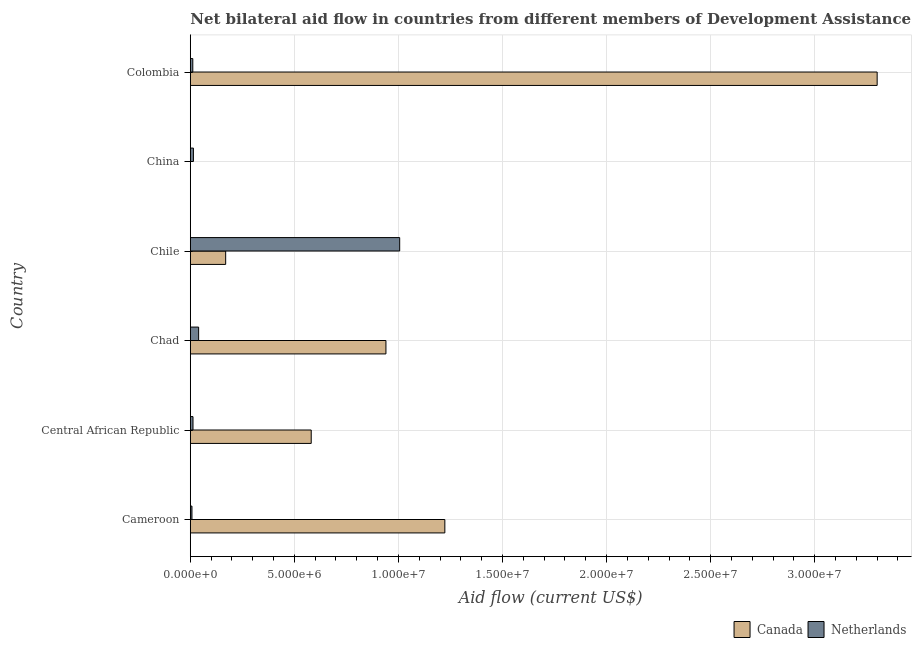Are the number of bars on each tick of the Y-axis equal?
Your response must be concise. No. How many bars are there on the 6th tick from the top?
Your response must be concise. 2. In how many cases, is the number of bars for a given country not equal to the number of legend labels?
Provide a short and direct response. 1. What is the amount of aid given by netherlands in Cameroon?
Give a very brief answer. 8.00e+04. Across all countries, what is the maximum amount of aid given by canada?
Provide a succinct answer. 3.30e+07. Across all countries, what is the minimum amount of aid given by canada?
Provide a succinct answer. 0. What is the total amount of aid given by netherlands in the graph?
Offer a very short reply. 1.09e+07. What is the difference between the amount of aid given by canada in Chad and that in Colombia?
Ensure brevity in your answer.  -2.36e+07. What is the difference between the amount of aid given by canada in Cameroon and the amount of aid given by netherlands in Chile?
Give a very brief answer. 2.17e+06. What is the average amount of aid given by netherlands per country?
Offer a very short reply. 1.82e+06. What is the difference between the amount of aid given by netherlands and amount of aid given by canada in Central African Republic?
Provide a succinct answer. -5.68e+06. In how many countries, is the amount of aid given by netherlands greater than 7000000 US$?
Ensure brevity in your answer.  1. What is the ratio of the amount of aid given by canada in Cameroon to that in Chile?
Keep it short and to the point. 7.19. Is the amount of aid given by netherlands in Cameroon less than that in Chad?
Ensure brevity in your answer.  Yes. What is the difference between the highest and the second highest amount of aid given by netherlands?
Make the answer very short. 9.66e+06. What is the difference between the highest and the lowest amount of aid given by canada?
Provide a short and direct response. 3.30e+07. How many bars are there?
Offer a very short reply. 11. Are all the bars in the graph horizontal?
Your response must be concise. Yes. What is the difference between two consecutive major ticks on the X-axis?
Make the answer very short. 5.00e+06. Are the values on the major ticks of X-axis written in scientific E-notation?
Your answer should be compact. Yes. Does the graph contain any zero values?
Offer a very short reply. Yes. Where does the legend appear in the graph?
Give a very brief answer. Bottom right. How are the legend labels stacked?
Give a very brief answer. Horizontal. What is the title of the graph?
Offer a very short reply. Net bilateral aid flow in countries from different members of Development Assistance Committee. What is the label or title of the X-axis?
Ensure brevity in your answer.  Aid flow (current US$). What is the label or title of the Y-axis?
Provide a short and direct response. Country. What is the Aid flow (current US$) in Canada in Cameroon?
Your answer should be very brief. 1.22e+07. What is the Aid flow (current US$) in Netherlands in Cameroon?
Provide a succinct answer. 8.00e+04. What is the Aid flow (current US$) of Canada in Central African Republic?
Your response must be concise. 5.81e+06. What is the Aid flow (current US$) in Canada in Chad?
Keep it short and to the point. 9.40e+06. What is the Aid flow (current US$) of Netherlands in Chad?
Offer a terse response. 4.00e+05. What is the Aid flow (current US$) of Canada in Chile?
Your response must be concise. 1.70e+06. What is the Aid flow (current US$) of Netherlands in Chile?
Provide a short and direct response. 1.01e+07. What is the Aid flow (current US$) in Canada in China?
Make the answer very short. 0. What is the Aid flow (current US$) of Netherlands in China?
Provide a short and direct response. 1.50e+05. What is the Aid flow (current US$) of Canada in Colombia?
Provide a succinct answer. 3.30e+07. What is the Aid flow (current US$) in Netherlands in Colombia?
Offer a very short reply. 1.20e+05. Across all countries, what is the maximum Aid flow (current US$) of Canada?
Provide a succinct answer. 3.30e+07. Across all countries, what is the maximum Aid flow (current US$) in Netherlands?
Offer a terse response. 1.01e+07. Across all countries, what is the minimum Aid flow (current US$) of Canada?
Offer a very short reply. 0. What is the total Aid flow (current US$) of Canada in the graph?
Your answer should be very brief. 6.21e+07. What is the total Aid flow (current US$) in Netherlands in the graph?
Provide a short and direct response. 1.09e+07. What is the difference between the Aid flow (current US$) of Canada in Cameroon and that in Central African Republic?
Provide a succinct answer. 6.42e+06. What is the difference between the Aid flow (current US$) in Netherlands in Cameroon and that in Central African Republic?
Provide a short and direct response. -5.00e+04. What is the difference between the Aid flow (current US$) in Canada in Cameroon and that in Chad?
Your answer should be compact. 2.83e+06. What is the difference between the Aid flow (current US$) of Netherlands in Cameroon and that in Chad?
Ensure brevity in your answer.  -3.20e+05. What is the difference between the Aid flow (current US$) of Canada in Cameroon and that in Chile?
Offer a very short reply. 1.05e+07. What is the difference between the Aid flow (current US$) in Netherlands in Cameroon and that in Chile?
Provide a short and direct response. -9.98e+06. What is the difference between the Aid flow (current US$) in Netherlands in Cameroon and that in China?
Provide a short and direct response. -7.00e+04. What is the difference between the Aid flow (current US$) in Canada in Cameroon and that in Colombia?
Provide a succinct answer. -2.08e+07. What is the difference between the Aid flow (current US$) in Canada in Central African Republic and that in Chad?
Offer a terse response. -3.59e+06. What is the difference between the Aid flow (current US$) in Netherlands in Central African Republic and that in Chad?
Provide a short and direct response. -2.70e+05. What is the difference between the Aid flow (current US$) in Canada in Central African Republic and that in Chile?
Your answer should be very brief. 4.11e+06. What is the difference between the Aid flow (current US$) in Netherlands in Central African Republic and that in Chile?
Provide a succinct answer. -9.93e+06. What is the difference between the Aid flow (current US$) of Netherlands in Central African Republic and that in China?
Make the answer very short. -2.00e+04. What is the difference between the Aid flow (current US$) of Canada in Central African Republic and that in Colombia?
Your answer should be compact. -2.72e+07. What is the difference between the Aid flow (current US$) in Netherlands in Central African Republic and that in Colombia?
Your answer should be very brief. 10000. What is the difference between the Aid flow (current US$) of Canada in Chad and that in Chile?
Your answer should be very brief. 7.70e+06. What is the difference between the Aid flow (current US$) of Netherlands in Chad and that in Chile?
Provide a succinct answer. -9.66e+06. What is the difference between the Aid flow (current US$) in Canada in Chad and that in Colombia?
Your answer should be very brief. -2.36e+07. What is the difference between the Aid flow (current US$) in Netherlands in Chad and that in Colombia?
Offer a terse response. 2.80e+05. What is the difference between the Aid flow (current US$) of Netherlands in Chile and that in China?
Offer a very short reply. 9.91e+06. What is the difference between the Aid flow (current US$) in Canada in Chile and that in Colombia?
Offer a terse response. -3.13e+07. What is the difference between the Aid flow (current US$) of Netherlands in Chile and that in Colombia?
Offer a very short reply. 9.94e+06. What is the difference between the Aid flow (current US$) in Netherlands in China and that in Colombia?
Make the answer very short. 3.00e+04. What is the difference between the Aid flow (current US$) of Canada in Cameroon and the Aid flow (current US$) of Netherlands in Central African Republic?
Offer a terse response. 1.21e+07. What is the difference between the Aid flow (current US$) in Canada in Cameroon and the Aid flow (current US$) in Netherlands in Chad?
Your response must be concise. 1.18e+07. What is the difference between the Aid flow (current US$) in Canada in Cameroon and the Aid flow (current US$) in Netherlands in Chile?
Make the answer very short. 2.17e+06. What is the difference between the Aid flow (current US$) in Canada in Cameroon and the Aid flow (current US$) in Netherlands in China?
Offer a terse response. 1.21e+07. What is the difference between the Aid flow (current US$) of Canada in Cameroon and the Aid flow (current US$) of Netherlands in Colombia?
Make the answer very short. 1.21e+07. What is the difference between the Aid flow (current US$) of Canada in Central African Republic and the Aid flow (current US$) of Netherlands in Chad?
Give a very brief answer. 5.41e+06. What is the difference between the Aid flow (current US$) of Canada in Central African Republic and the Aid flow (current US$) of Netherlands in Chile?
Offer a terse response. -4.25e+06. What is the difference between the Aid flow (current US$) of Canada in Central African Republic and the Aid flow (current US$) of Netherlands in China?
Provide a short and direct response. 5.66e+06. What is the difference between the Aid flow (current US$) of Canada in Central African Republic and the Aid flow (current US$) of Netherlands in Colombia?
Your answer should be very brief. 5.69e+06. What is the difference between the Aid flow (current US$) of Canada in Chad and the Aid flow (current US$) of Netherlands in Chile?
Your answer should be compact. -6.60e+05. What is the difference between the Aid flow (current US$) of Canada in Chad and the Aid flow (current US$) of Netherlands in China?
Your response must be concise. 9.25e+06. What is the difference between the Aid flow (current US$) of Canada in Chad and the Aid flow (current US$) of Netherlands in Colombia?
Provide a succinct answer. 9.28e+06. What is the difference between the Aid flow (current US$) of Canada in Chile and the Aid flow (current US$) of Netherlands in China?
Your answer should be compact. 1.55e+06. What is the difference between the Aid flow (current US$) of Canada in Chile and the Aid flow (current US$) of Netherlands in Colombia?
Make the answer very short. 1.58e+06. What is the average Aid flow (current US$) in Canada per country?
Your response must be concise. 1.04e+07. What is the average Aid flow (current US$) of Netherlands per country?
Keep it short and to the point. 1.82e+06. What is the difference between the Aid flow (current US$) of Canada and Aid flow (current US$) of Netherlands in Cameroon?
Your response must be concise. 1.22e+07. What is the difference between the Aid flow (current US$) of Canada and Aid flow (current US$) of Netherlands in Central African Republic?
Ensure brevity in your answer.  5.68e+06. What is the difference between the Aid flow (current US$) of Canada and Aid flow (current US$) of Netherlands in Chad?
Ensure brevity in your answer.  9.00e+06. What is the difference between the Aid flow (current US$) of Canada and Aid flow (current US$) of Netherlands in Chile?
Offer a very short reply. -8.36e+06. What is the difference between the Aid flow (current US$) of Canada and Aid flow (current US$) of Netherlands in Colombia?
Offer a terse response. 3.29e+07. What is the ratio of the Aid flow (current US$) in Canada in Cameroon to that in Central African Republic?
Provide a short and direct response. 2.1. What is the ratio of the Aid flow (current US$) of Netherlands in Cameroon to that in Central African Republic?
Offer a terse response. 0.62. What is the ratio of the Aid flow (current US$) in Canada in Cameroon to that in Chad?
Your answer should be compact. 1.3. What is the ratio of the Aid flow (current US$) in Canada in Cameroon to that in Chile?
Provide a succinct answer. 7.19. What is the ratio of the Aid flow (current US$) in Netherlands in Cameroon to that in Chile?
Provide a succinct answer. 0.01. What is the ratio of the Aid flow (current US$) in Netherlands in Cameroon to that in China?
Make the answer very short. 0.53. What is the ratio of the Aid flow (current US$) in Canada in Cameroon to that in Colombia?
Your answer should be compact. 0.37. What is the ratio of the Aid flow (current US$) in Canada in Central African Republic to that in Chad?
Provide a succinct answer. 0.62. What is the ratio of the Aid flow (current US$) of Netherlands in Central African Republic to that in Chad?
Your answer should be compact. 0.33. What is the ratio of the Aid flow (current US$) in Canada in Central African Republic to that in Chile?
Provide a succinct answer. 3.42. What is the ratio of the Aid flow (current US$) of Netherlands in Central African Republic to that in Chile?
Your answer should be very brief. 0.01. What is the ratio of the Aid flow (current US$) of Netherlands in Central African Republic to that in China?
Your answer should be very brief. 0.87. What is the ratio of the Aid flow (current US$) in Canada in Central African Republic to that in Colombia?
Give a very brief answer. 0.18. What is the ratio of the Aid flow (current US$) of Canada in Chad to that in Chile?
Your answer should be very brief. 5.53. What is the ratio of the Aid flow (current US$) of Netherlands in Chad to that in Chile?
Your response must be concise. 0.04. What is the ratio of the Aid flow (current US$) of Netherlands in Chad to that in China?
Offer a terse response. 2.67. What is the ratio of the Aid flow (current US$) in Canada in Chad to that in Colombia?
Offer a terse response. 0.28. What is the ratio of the Aid flow (current US$) in Netherlands in Chad to that in Colombia?
Keep it short and to the point. 3.33. What is the ratio of the Aid flow (current US$) in Netherlands in Chile to that in China?
Make the answer very short. 67.07. What is the ratio of the Aid flow (current US$) in Canada in Chile to that in Colombia?
Your answer should be compact. 0.05. What is the ratio of the Aid flow (current US$) of Netherlands in Chile to that in Colombia?
Keep it short and to the point. 83.83. What is the ratio of the Aid flow (current US$) in Netherlands in China to that in Colombia?
Provide a succinct answer. 1.25. What is the difference between the highest and the second highest Aid flow (current US$) in Canada?
Offer a terse response. 2.08e+07. What is the difference between the highest and the second highest Aid flow (current US$) in Netherlands?
Make the answer very short. 9.66e+06. What is the difference between the highest and the lowest Aid flow (current US$) in Canada?
Your answer should be very brief. 3.30e+07. What is the difference between the highest and the lowest Aid flow (current US$) in Netherlands?
Provide a short and direct response. 9.98e+06. 